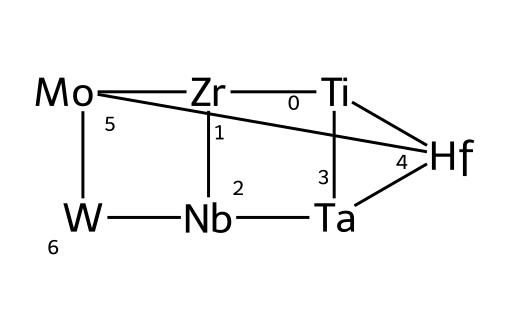What are the main metallic elements present in this structure? The SMILES representation contains Titanium (Ti), Zirconium (Zr), Niobium (Nb), Tantalum (Ta), Hafnium (Hf), Molybdenum (Mo), and Tungsten (W). Each of these elements is identified by its chemical symbol in the representation.
Answer: Titanium, Zirconium, Niobium, Tantalum, Hafnium, Molybdenum, Tungsten How many distinct metal atoms are in the alloy? By reviewing the SMILES notation, we count the different metal symbols present: Ti, Zr, Nb, Ta, Hf, Mo, and W. There are a total of 7 different metallic elements.
Answer: 7 Which element is in the first position of the structure? The first element indicated in the SMILES notation is Titanium, which appears first before the numeral indicating bonding. Thus, it is the first atom in the structure.
Answer: Titanium What is the total number of bonds implied in this alloy based on the numbers used? The numbers in the SMILES indicate the connectivity between the atoms in a cyclic pattern; each number corresponds to a bond. There are 4 unique cyclic structures indicated by the numbers 1, 2, 3, and 4 in the SMILES. This results in a total of 4 bonds per cycle, leading to a complex structure, but addressing only unique numbers shows 4 total bonds.
Answer: 4 How would you classify this alloy based on its constituent elements? This alloy consists primarily of transition metals, which are known for their unique combination of high melting points, strength, and resistance to corrosion. The presence of multiple transition metals suggests it can be categorized as a complex high-performance alloy.
Answer: Transition metal alloy Which metal in the structure is known for its high corrosion resistance? Hafnium (Hf) is specifically known for its excellent corrosion resistance, particularly in acidic environments. Upon examining the structure, it can be identified as one of the metals present.
Answer: Hafnium Which element contributes to the high-temperature stability of this alloy? Molybdenum (Mo) is well-known for its capability to withstand high temperatures and is thus a key contributor to the thermal stability of the alloy. In the structure, it is easily identifiable through its chemical symbol.
Answer: Molybdenum 